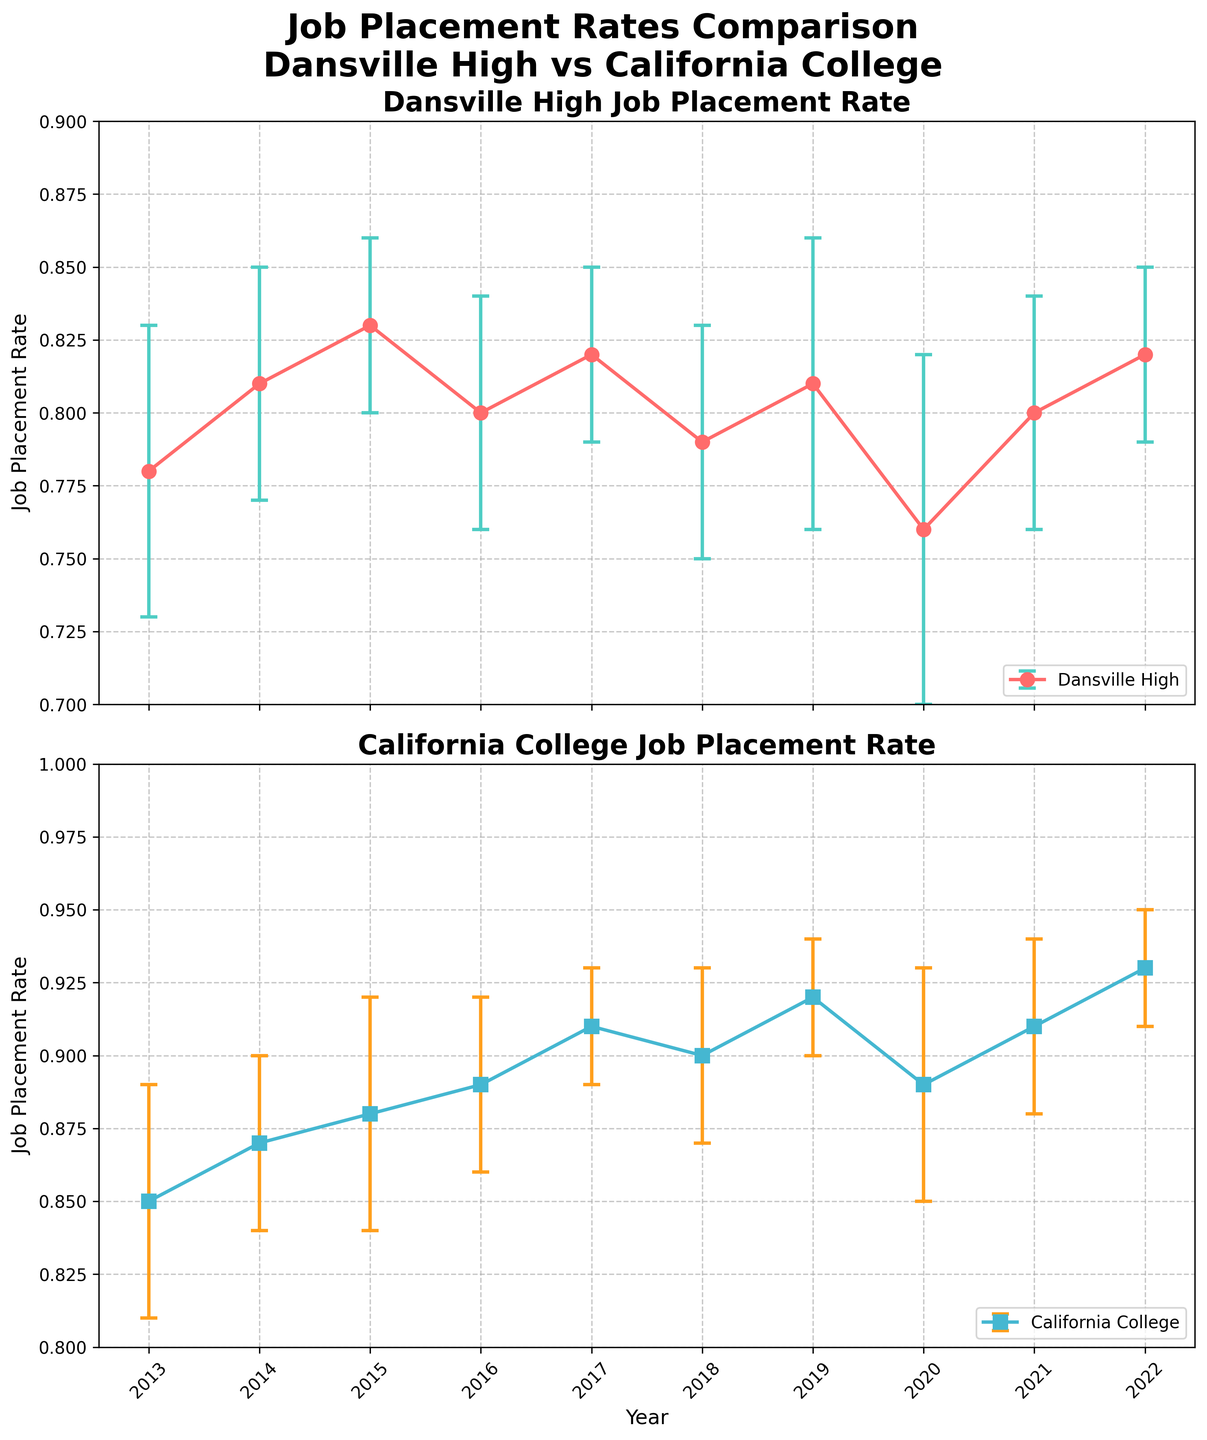What are the titles of the two subplots? The titles of the subplots are displayed at the top of each plot area, above the data points and error bars. The first subplot is titled "Dansville High Job Placement Rate," and the second subplot is titled "California College Job Placement Rate."
Answer: "Dansville High Job Placement Rate" and "California College Job Placement Rate" What's the job placement rate for Dansville High in 2016? To find this, locate the data point for the year 2016 on the Dansville High subplot. The job placement rate is marked along the y-axis. In 2016, the rate for Dansville High is 0.80.
Answer: 0.80 Which year had the lowest job placement rate for Dansville High? By visually scanning the Dansville High subplot, find the data point with the lowest position along the y-axis. This point corresponds to the year 2020 with a job placement rate of 0.76.
Answer: 2020 What is the range of job placement rates for California College over the past decade? To determine the range, identify the minimum and maximum job placement rates in the California College subplot. The minimum rate is 0.85 in 2013, and the maximum rate is 0.93 in 2022. The range is then calculated as 0.93 - 0.85 = 0.08.
Answer: 0.08 How did the job placement rates for Dansville High trend from 2013 to 2022? Observing the Dansville High subplot, the job placement rates show a fluctuating pattern with slight increases and decreases. The rates started at 0.78 in 2013, went through several fluctuations, and reached 0.82 in 2022.
Answer: Fluctuating What is the error margin for California College in 2015? Locate the data point for the year 2015 on the California College subplot and refer to the error bars extending up and down from the point. The error margin in 2015 is ±0.04.
Answer: ±0.04 Compare the job placement rates for both schools in 2019. Which one is higher? On the Dansville High subplot, the rate in 2019 is 0.81. On the California College subplot, the rate in 2019 is 0.92. Comparing these, California College's rate is higher in 2019.
Answer: California College What is the average job placement rate for Dansville High over the decade? Sum the job placement rates for Dansville High from 2013 to 2022 and divide by the number of years. \(\frac{0.78 + 0.81 + 0.83 + 0.80 + 0.82 + 0.79 + 0.81 + 0.76 + 0.80 + 0.82}{10} = 8.22 / 10 = 0.822\)
Answer: 0.822 In which year did California College have its highest job placement rate? Look for the highest data point in the California College subplot. The year with the highest job placement rate is 2022, with a rate of 0.93.
Answer: 2022 How does the error margin in 2020 compare between the two schools? In 2020, locate the error margins on both subplots. For Dansville High, the error margin is ±0.06, and for California College, it is ±0.04. Comparing these, Dansville High has a higher error margin in 2020.
Answer: Dansville High has a higher error margin 